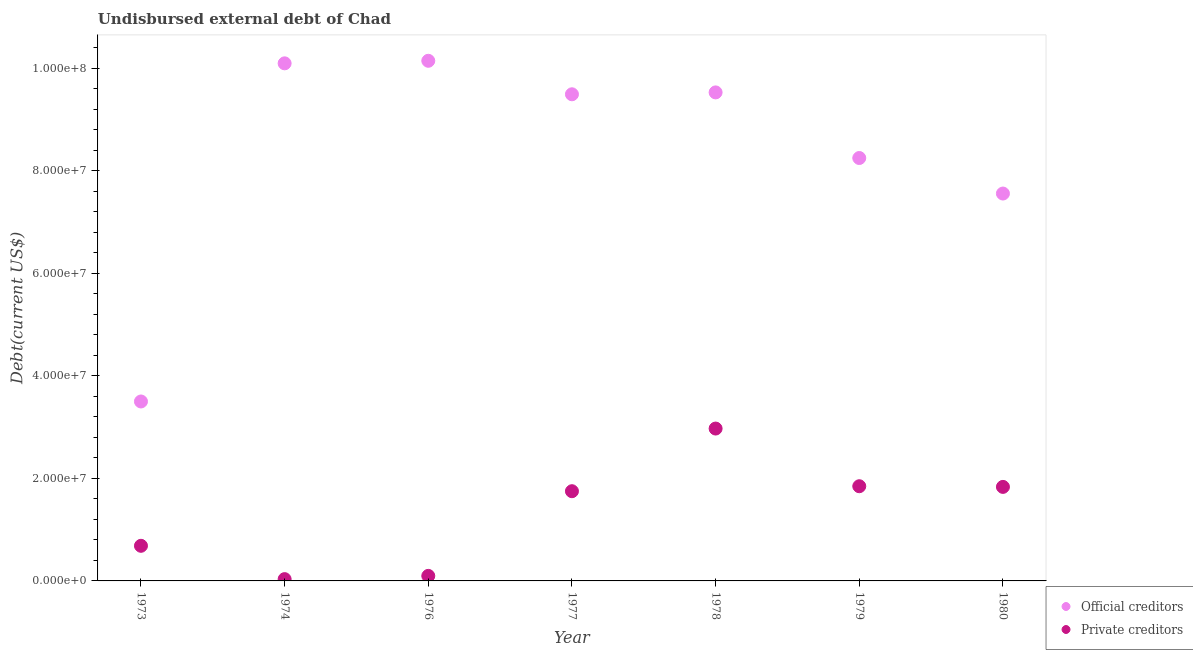What is the undisbursed external debt of official creditors in 1974?
Provide a succinct answer. 1.01e+08. Across all years, what is the maximum undisbursed external debt of official creditors?
Your answer should be compact. 1.01e+08. Across all years, what is the minimum undisbursed external debt of private creditors?
Offer a very short reply. 3.49e+05. In which year was the undisbursed external debt of official creditors maximum?
Your response must be concise. 1976. In which year was the undisbursed external debt of official creditors minimum?
Keep it short and to the point. 1973. What is the total undisbursed external debt of private creditors in the graph?
Ensure brevity in your answer.  9.22e+07. What is the difference between the undisbursed external debt of official creditors in 1974 and that in 1976?
Your answer should be very brief. -4.96e+05. What is the difference between the undisbursed external debt of official creditors in 1974 and the undisbursed external debt of private creditors in 1980?
Keep it short and to the point. 8.26e+07. What is the average undisbursed external debt of official creditors per year?
Your answer should be compact. 8.36e+07. In the year 1978, what is the difference between the undisbursed external debt of official creditors and undisbursed external debt of private creditors?
Give a very brief answer. 6.55e+07. In how many years, is the undisbursed external debt of private creditors greater than 56000000 US$?
Your answer should be compact. 0. What is the ratio of the undisbursed external debt of private creditors in 1976 to that in 1979?
Ensure brevity in your answer.  0.05. Is the undisbursed external debt of official creditors in 1973 less than that in 1976?
Provide a succinct answer. Yes. Is the difference between the undisbursed external debt of private creditors in 1973 and 1977 greater than the difference between the undisbursed external debt of official creditors in 1973 and 1977?
Provide a short and direct response. Yes. What is the difference between the highest and the second highest undisbursed external debt of official creditors?
Ensure brevity in your answer.  4.96e+05. What is the difference between the highest and the lowest undisbursed external debt of official creditors?
Your response must be concise. 6.64e+07. Is the sum of the undisbursed external debt of private creditors in 1976 and 1977 greater than the maximum undisbursed external debt of official creditors across all years?
Keep it short and to the point. No. Is the undisbursed external debt of private creditors strictly greater than the undisbursed external debt of official creditors over the years?
Provide a short and direct response. No. Is the undisbursed external debt of private creditors strictly less than the undisbursed external debt of official creditors over the years?
Give a very brief answer. Yes. How many dotlines are there?
Make the answer very short. 2. What is the difference between two consecutive major ticks on the Y-axis?
Your response must be concise. 2.00e+07. Does the graph contain grids?
Give a very brief answer. No. How are the legend labels stacked?
Your answer should be compact. Vertical. What is the title of the graph?
Offer a very short reply. Undisbursed external debt of Chad. What is the label or title of the Y-axis?
Make the answer very short. Debt(current US$). What is the Debt(current US$) of Official creditors in 1973?
Ensure brevity in your answer.  3.50e+07. What is the Debt(current US$) in Private creditors in 1973?
Your answer should be compact. 6.85e+06. What is the Debt(current US$) of Official creditors in 1974?
Keep it short and to the point. 1.01e+08. What is the Debt(current US$) of Private creditors in 1974?
Provide a short and direct response. 3.49e+05. What is the Debt(current US$) in Official creditors in 1976?
Provide a short and direct response. 1.01e+08. What is the Debt(current US$) of Private creditors in 1976?
Your answer should be very brief. 9.82e+05. What is the Debt(current US$) in Official creditors in 1977?
Your answer should be very brief. 9.49e+07. What is the Debt(current US$) in Private creditors in 1977?
Keep it short and to the point. 1.75e+07. What is the Debt(current US$) of Official creditors in 1978?
Provide a short and direct response. 9.53e+07. What is the Debt(current US$) of Private creditors in 1978?
Offer a very short reply. 2.97e+07. What is the Debt(current US$) in Official creditors in 1979?
Provide a short and direct response. 8.25e+07. What is the Debt(current US$) in Private creditors in 1979?
Make the answer very short. 1.85e+07. What is the Debt(current US$) in Official creditors in 1980?
Provide a succinct answer. 7.55e+07. What is the Debt(current US$) in Private creditors in 1980?
Offer a very short reply. 1.83e+07. Across all years, what is the maximum Debt(current US$) of Official creditors?
Ensure brevity in your answer.  1.01e+08. Across all years, what is the maximum Debt(current US$) in Private creditors?
Provide a short and direct response. 2.97e+07. Across all years, what is the minimum Debt(current US$) in Official creditors?
Your response must be concise. 3.50e+07. Across all years, what is the minimum Debt(current US$) in Private creditors?
Offer a very short reply. 3.49e+05. What is the total Debt(current US$) in Official creditors in the graph?
Your answer should be very brief. 5.85e+08. What is the total Debt(current US$) in Private creditors in the graph?
Your answer should be compact. 9.22e+07. What is the difference between the Debt(current US$) of Official creditors in 1973 and that in 1974?
Your response must be concise. -6.59e+07. What is the difference between the Debt(current US$) in Private creditors in 1973 and that in 1974?
Provide a short and direct response. 6.50e+06. What is the difference between the Debt(current US$) in Official creditors in 1973 and that in 1976?
Make the answer very short. -6.64e+07. What is the difference between the Debt(current US$) in Private creditors in 1973 and that in 1976?
Make the answer very short. 5.86e+06. What is the difference between the Debt(current US$) of Official creditors in 1973 and that in 1977?
Offer a very short reply. -5.99e+07. What is the difference between the Debt(current US$) of Private creditors in 1973 and that in 1977?
Your response must be concise. -1.06e+07. What is the difference between the Debt(current US$) of Official creditors in 1973 and that in 1978?
Offer a very short reply. -6.03e+07. What is the difference between the Debt(current US$) of Private creditors in 1973 and that in 1978?
Give a very brief answer. -2.29e+07. What is the difference between the Debt(current US$) of Official creditors in 1973 and that in 1979?
Your answer should be compact. -4.75e+07. What is the difference between the Debt(current US$) of Private creditors in 1973 and that in 1979?
Provide a short and direct response. -1.16e+07. What is the difference between the Debt(current US$) in Official creditors in 1973 and that in 1980?
Your answer should be compact. -4.05e+07. What is the difference between the Debt(current US$) in Private creditors in 1973 and that in 1980?
Provide a short and direct response. -1.15e+07. What is the difference between the Debt(current US$) of Official creditors in 1974 and that in 1976?
Offer a very short reply. -4.96e+05. What is the difference between the Debt(current US$) of Private creditors in 1974 and that in 1976?
Make the answer very short. -6.33e+05. What is the difference between the Debt(current US$) of Official creditors in 1974 and that in 1977?
Make the answer very short. 6.04e+06. What is the difference between the Debt(current US$) in Private creditors in 1974 and that in 1977?
Ensure brevity in your answer.  -1.71e+07. What is the difference between the Debt(current US$) in Official creditors in 1974 and that in 1978?
Give a very brief answer. 5.67e+06. What is the difference between the Debt(current US$) in Private creditors in 1974 and that in 1978?
Keep it short and to the point. -2.94e+07. What is the difference between the Debt(current US$) of Official creditors in 1974 and that in 1979?
Offer a very short reply. 1.85e+07. What is the difference between the Debt(current US$) of Private creditors in 1974 and that in 1979?
Your answer should be compact. -1.81e+07. What is the difference between the Debt(current US$) of Official creditors in 1974 and that in 1980?
Offer a very short reply. 2.54e+07. What is the difference between the Debt(current US$) in Private creditors in 1974 and that in 1980?
Your answer should be compact. -1.80e+07. What is the difference between the Debt(current US$) of Official creditors in 1976 and that in 1977?
Offer a terse response. 6.53e+06. What is the difference between the Debt(current US$) in Private creditors in 1976 and that in 1977?
Provide a succinct answer. -1.65e+07. What is the difference between the Debt(current US$) of Official creditors in 1976 and that in 1978?
Give a very brief answer. 6.16e+06. What is the difference between the Debt(current US$) in Private creditors in 1976 and that in 1978?
Provide a short and direct response. -2.87e+07. What is the difference between the Debt(current US$) of Official creditors in 1976 and that in 1979?
Make the answer very short. 1.90e+07. What is the difference between the Debt(current US$) of Private creditors in 1976 and that in 1979?
Your response must be concise. -1.75e+07. What is the difference between the Debt(current US$) in Official creditors in 1976 and that in 1980?
Provide a short and direct response. 2.59e+07. What is the difference between the Debt(current US$) in Private creditors in 1976 and that in 1980?
Offer a terse response. -1.74e+07. What is the difference between the Debt(current US$) of Official creditors in 1977 and that in 1978?
Provide a short and direct response. -3.67e+05. What is the difference between the Debt(current US$) in Private creditors in 1977 and that in 1978?
Make the answer very short. -1.22e+07. What is the difference between the Debt(current US$) of Official creditors in 1977 and that in 1979?
Keep it short and to the point. 1.24e+07. What is the difference between the Debt(current US$) in Private creditors in 1977 and that in 1979?
Provide a short and direct response. -9.70e+05. What is the difference between the Debt(current US$) in Official creditors in 1977 and that in 1980?
Keep it short and to the point. 1.94e+07. What is the difference between the Debt(current US$) in Private creditors in 1977 and that in 1980?
Offer a terse response. -8.40e+05. What is the difference between the Debt(current US$) in Official creditors in 1978 and that in 1979?
Make the answer very short. 1.28e+07. What is the difference between the Debt(current US$) of Private creditors in 1978 and that in 1979?
Offer a terse response. 1.12e+07. What is the difference between the Debt(current US$) in Official creditors in 1978 and that in 1980?
Ensure brevity in your answer.  1.97e+07. What is the difference between the Debt(current US$) of Private creditors in 1978 and that in 1980?
Offer a very short reply. 1.14e+07. What is the difference between the Debt(current US$) of Official creditors in 1979 and that in 1980?
Make the answer very short. 6.93e+06. What is the difference between the Debt(current US$) in Private creditors in 1979 and that in 1980?
Your answer should be compact. 1.30e+05. What is the difference between the Debt(current US$) in Official creditors in 1973 and the Debt(current US$) in Private creditors in 1974?
Ensure brevity in your answer.  3.46e+07. What is the difference between the Debt(current US$) of Official creditors in 1973 and the Debt(current US$) of Private creditors in 1976?
Offer a terse response. 3.40e+07. What is the difference between the Debt(current US$) of Official creditors in 1973 and the Debt(current US$) of Private creditors in 1977?
Your answer should be compact. 1.75e+07. What is the difference between the Debt(current US$) of Official creditors in 1973 and the Debt(current US$) of Private creditors in 1978?
Your response must be concise. 5.28e+06. What is the difference between the Debt(current US$) in Official creditors in 1973 and the Debt(current US$) in Private creditors in 1979?
Make the answer very short. 1.65e+07. What is the difference between the Debt(current US$) of Official creditors in 1973 and the Debt(current US$) of Private creditors in 1980?
Make the answer very short. 1.67e+07. What is the difference between the Debt(current US$) of Official creditors in 1974 and the Debt(current US$) of Private creditors in 1976?
Your answer should be compact. 9.99e+07. What is the difference between the Debt(current US$) in Official creditors in 1974 and the Debt(current US$) in Private creditors in 1977?
Provide a short and direct response. 8.34e+07. What is the difference between the Debt(current US$) in Official creditors in 1974 and the Debt(current US$) in Private creditors in 1978?
Your answer should be very brief. 7.12e+07. What is the difference between the Debt(current US$) of Official creditors in 1974 and the Debt(current US$) of Private creditors in 1979?
Keep it short and to the point. 8.25e+07. What is the difference between the Debt(current US$) in Official creditors in 1974 and the Debt(current US$) in Private creditors in 1980?
Provide a short and direct response. 8.26e+07. What is the difference between the Debt(current US$) in Official creditors in 1976 and the Debt(current US$) in Private creditors in 1977?
Offer a terse response. 8.39e+07. What is the difference between the Debt(current US$) of Official creditors in 1976 and the Debt(current US$) of Private creditors in 1978?
Your response must be concise. 7.17e+07. What is the difference between the Debt(current US$) of Official creditors in 1976 and the Debt(current US$) of Private creditors in 1979?
Your answer should be compact. 8.30e+07. What is the difference between the Debt(current US$) of Official creditors in 1976 and the Debt(current US$) of Private creditors in 1980?
Your answer should be very brief. 8.31e+07. What is the difference between the Debt(current US$) of Official creditors in 1977 and the Debt(current US$) of Private creditors in 1978?
Provide a succinct answer. 6.52e+07. What is the difference between the Debt(current US$) in Official creditors in 1977 and the Debt(current US$) in Private creditors in 1979?
Offer a very short reply. 7.64e+07. What is the difference between the Debt(current US$) in Official creditors in 1977 and the Debt(current US$) in Private creditors in 1980?
Keep it short and to the point. 7.66e+07. What is the difference between the Debt(current US$) of Official creditors in 1978 and the Debt(current US$) of Private creditors in 1979?
Your response must be concise. 7.68e+07. What is the difference between the Debt(current US$) of Official creditors in 1978 and the Debt(current US$) of Private creditors in 1980?
Your answer should be very brief. 7.69e+07. What is the difference between the Debt(current US$) in Official creditors in 1979 and the Debt(current US$) in Private creditors in 1980?
Offer a very short reply. 6.41e+07. What is the average Debt(current US$) of Official creditors per year?
Provide a short and direct response. 8.36e+07. What is the average Debt(current US$) in Private creditors per year?
Offer a terse response. 1.32e+07. In the year 1973, what is the difference between the Debt(current US$) in Official creditors and Debt(current US$) in Private creditors?
Provide a succinct answer. 2.81e+07. In the year 1974, what is the difference between the Debt(current US$) of Official creditors and Debt(current US$) of Private creditors?
Your response must be concise. 1.01e+08. In the year 1976, what is the difference between the Debt(current US$) of Official creditors and Debt(current US$) of Private creditors?
Provide a succinct answer. 1.00e+08. In the year 1977, what is the difference between the Debt(current US$) of Official creditors and Debt(current US$) of Private creditors?
Make the answer very short. 7.74e+07. In the year 1978, what is the difference between the Debt(current US$) of Official creditors and Debt(current US$) of Private creditors?
Your answer should be very brief. 6.55e+07. In the year 1979, what is the difference between the Debt(current US$) in Official creditors and Debt(current US$) in Private creditors?
Keep it short and to the point. 6.40e+07. In the year 1980, what is the difference between the Debt(current US$) in Official creditors and Debt(current US$) in Private creditors?
Your answer should be very brief. 5.72e+07. What is the ratio of the Debt(current US$) in Official creditors in 1973 to that in 1974?
Offer a terse response. 0.35. What is the ratio of the Debt(current US$) of Private creditors in 1973 to that in 1974?
Give a very brief answer. 19.62. What is the ratio of the Debt(current US$) of Official creditors in 1973 to that in 1976?
Make the answer very short. 0.34. What is the ratio of the Debt(current US$) in Private creditors in 1973 to that in 1976?
Make the answer very short. 6.97. What is the ratio of the Debt(current US$) in Official creditors in 1973 to that in 1977?
Your answer should be compact. 0.37. What is the ratio of the Debt(current US$) in Private creditors in 1973 to that in 1977?
Your answer should be very brief. 0.39. What is the ratio of the Debt(current US$) of Official creditors in 1973 to that in 1978?
Your response must be concise. 0.37. What is the ratio of the Debt(current US$) in Private creditors in 1973 to that in 1978?
Offer a very short reply. 0.23. What is the ratio of the Debt(current US$) in Official creditors in 1973 to that in 1979?
Offer a terse response. 0.42. What is the ratio of the Debt(current US$) of Private creditors in 1973 to that in 1979?
Your answer should be very brief. 0.37. What is the ratio of the Debt(current US$) in Official creditors in 1973 to that in 1980?
Make the answer very short. 0.46. What is the ratio of the Debt(current US$) of Private creditors in 1973 to that in 1980?
Make the answer very short. 0.37. What is the ratio of the Debt(current US$) of Official creditors in 1974 to that in 1976?
Your answer should be very brief. 1. What is the ratio of the Debt(current US$) of Private creditors in 1974 to that in 1976?
Your response must be concise. 0.36. What is the ratio of the Debt(current US$) of Official creditors in 1974 to that in 1977?
Your answer should be very brief. 1.06. What is the ratio of the Debt(current US$) in Private creditors in 1974 to that in 1977?
Your answer should be compact. 0.02. What is the ratio of the Debt(current US$) of Official creditors in 1974 to that in 1978?
Offer a very short reply. 1.06. What is the ratio of the Debt(current US$) of Private creditors in 1974 to that in 1978?
Your response must be concise. 0.01. What is the ratio of the Debt(current US$) in Official creditors in 1974 to that in 1979?
Offer a terse response. 1.22. What is the ratio of the Debt(current US$) of Private creditors in 1974 to that in 1979?
Your answer should be compact. 0.02. What is the ratio of the Debt(current US$) of Official creditors in 1974 to that in 1980?
Your response must be concise. 1.34. What is the ratio of the Debt(current US$) in Private creditors in 1974 to that in 1980?
Give a very brief answer. 0.02. What is the ratio of the Debt(current US$) in Official creditors in 1976 to that in 1977?
Provide a short and direct response. 1.07. What is the ratio of the Debt(current US$) of Private creditors in 1976 to that in 1977?
Make the answer very short. 0.06. What is the ratio of the Debt(current US$) in Official creditors in 1976 to that in 1978?
Ensure brevity in your answer.  1.06. What is the ratio of the Debt(current US$) of Private creditors in 1976 to that in 1978?
Give a very brief answer. 0.03. What is the ratio of the Debt(current US$) in Official creditors in 1976 to that in 1979?
Your response must be concise. 1.23. What is the ratio of the Debt(current US$) of Private creditors in 1976 to that in 1979?
Your answer should be compact. 0.05. What is the ratio of the Debt(current US$) in Official creditors in 1976 to that in 1980?
Offer a terse response. 1.34. What is the ratio of the Debt(current US$) in Private creditors in 1976 to that in 1980?
Provide a short and direct response. 0.05. What is the ratio of the Debt(current US$) in Private creditors in 1977 to that in 1978?
Make the answer very short. 0.59. What is the ratio of the Debt(current US$) of Official creditors in 1977 to that in 1979?
Offer a very short reply. 1.15. What is the ratio of the Debt(current US$) in Private creditors in 1977 to that in 1979?
Provide a short and direct response. 0.95. What is the ratio of the Debt(current US$) in Official creditors in 1977 to that in 1980?
Make the answer very short. 1.26. What is the ratio of the Debt(current US$) of Private creditors in 1977 to that in 1980?
Your answer should be compact. 0.95. What is the ratio of the Debt(current US$) of Official creditors in 1978 to that in 1979?
Ensure brevity in your answer.  1.16. What is the ratio of the Debt(current US$) of Private creditors in 1978 to that in 1979?
Provide a short and direct response. 1.61. What is the ratio of the Debt(current US$) of Official creditors in 1978 to that in 1980?
Offer a very short reply. 1.26. What is the ratio of the Debt(current US$) in Private creditors in 1978 to that in 1980?
Give a very brief answer. 1.62. What is the ratio of the Debt(current US$) in Official creditors in 1979 to that in 1980?
Your answer should be very brief. 1.09. What is the ratio of the Debt(current US$) in Private creditors in 1979 to that in 1980?
Offer a very short reply. 1.01. What is the difference between the highest and the second highest Debt(current US$) in Official creditors?
Provide a succinct answer. 4.96e+05. What is the difference between the highest and the second highest Debt(current US$) in Private creditors?
Your answer should be very brief. 1.12e+07. What is the difference between the highest and the lowest Debt(current US$) of Official creditors?
Provide a succinct answer. 6.64e+07. What is the difference between the highest and the lowest Debt(current US$) in Private creditors?
Ensure brevity in your answer.  2.94e+07. 